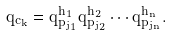Convert formula to latex. <formula><loc_0><loc_0><loc_500><loc_500>q _ { c _ { k } } = q _ { p _ { j _ { 1 } } } ^ { h _ { 1 } } q _ { p _ { j _ { 2 } } } ^ { h _ { 2 } } \cdots q _ { p _ { j _ { n } } } ^ { h _ { n } } .</formula> 